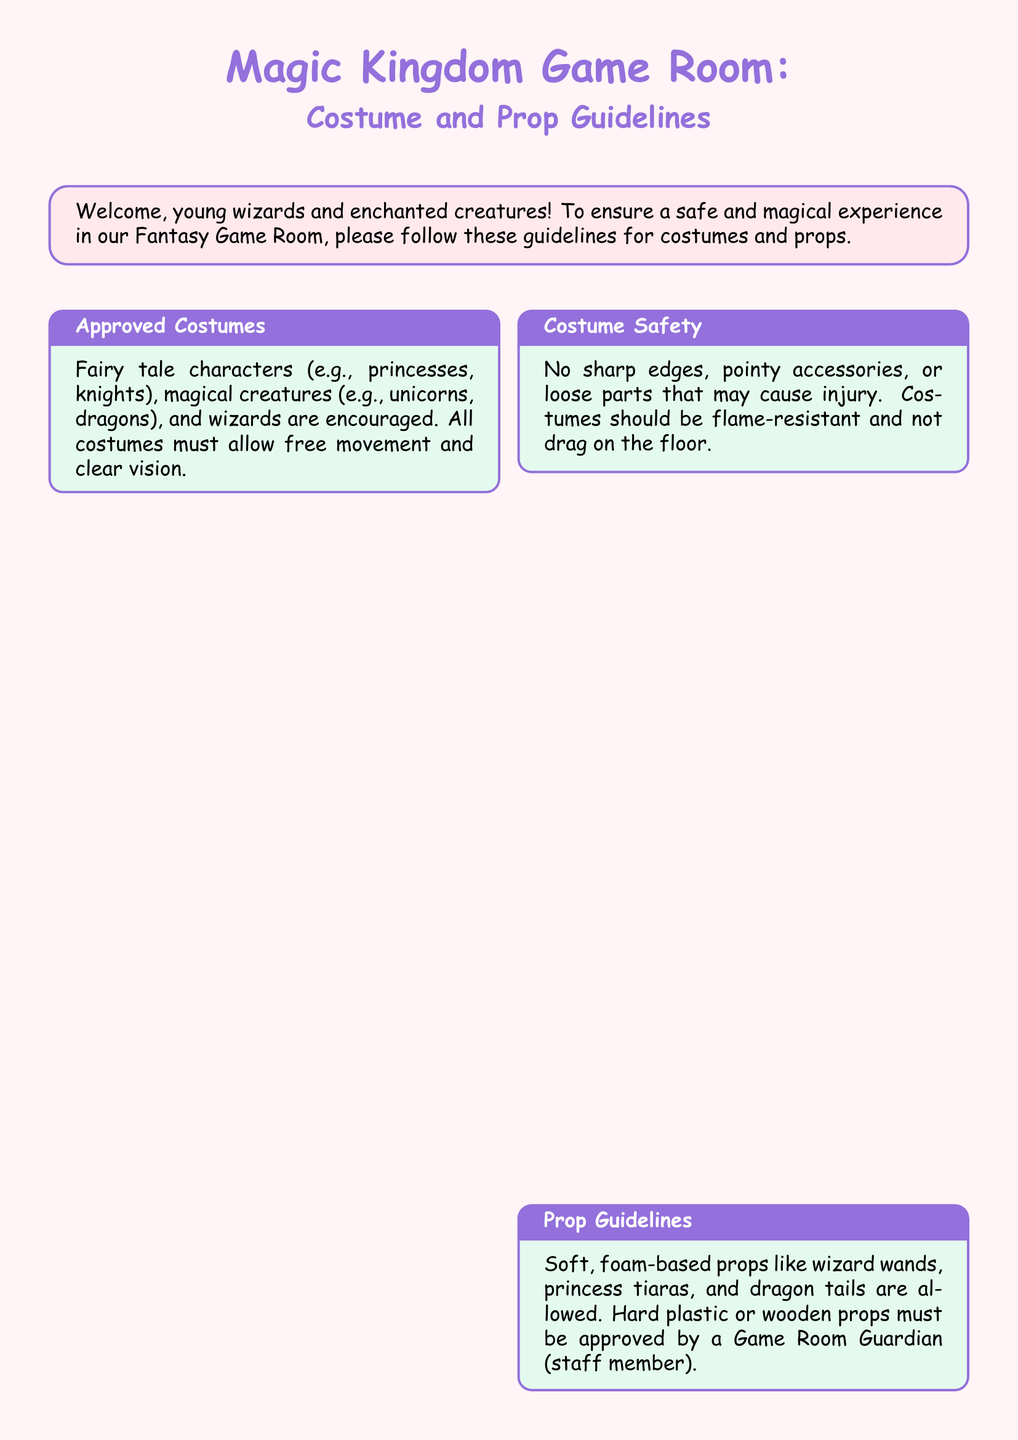What are the approved costumes? The approved costumes include fairy tale characters, magical creatures, and wizards, which are encouraged for use in the game room.
Answer: Fairy tale characters, magical creatures, wizards What type of props are allowed? The type of props that are allowed in the game room are soft, foam-based props, while hard plastic or wooden props must be approved.
Answer: Soft, foam-based props What items are restricted? Restricted items include real weapons, toy guns, swords, and masks that cover the entire face for safety reasons.
Answer: Real weapons, masks What is the purpose of the Transformation Chamber? The Transformation Chamber is designated for costume changes, allowing players to change their attire comfortably.
Answer: Costume changes What delicate items need care? The delicate items that require careful handling under supervision include the Enchanted Mirror, Crystal Ball, and Sorting Hat.
Answer: Enchanted Mirror, Crystal Ball, Sorting Hat What should costumes allow for safety? For safety, costumes must allow for free movement and clear vision to ensure everyone can enjoy their time in the game room.
Answer: Free movement, clear vision How must costumes be constructed? Costumes must be flame-resistant and should not drag on the floor to avoid safety hazards.
Answer: Flame-resistant, not drag What is provided for personal belongings? 'Treasure Chests' are provided in the game room for players to keep their personal belongings.
Answer: Treasure Chests 